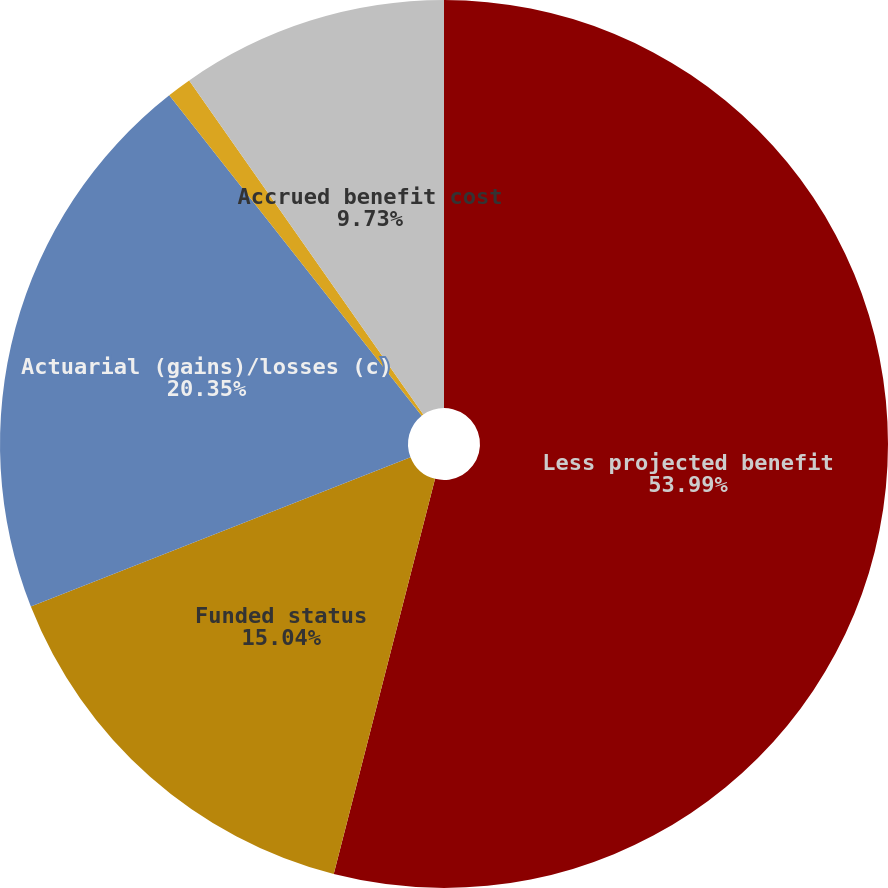Convert chart. <chart><loc_0><loc_0><loc_500><loc_500><pie_chart><fcel>Less projected benefit<fcel>Funded status<fcel>Actuarial (gains)/losses (c)<fcel>Net amount recognized<fcel>Accrued benefit cost<nl><fcel>54.0%<fcel>15.04%<fcel>20.35%<fcel>0.89%<fcel>9.73%<nl></chart> 